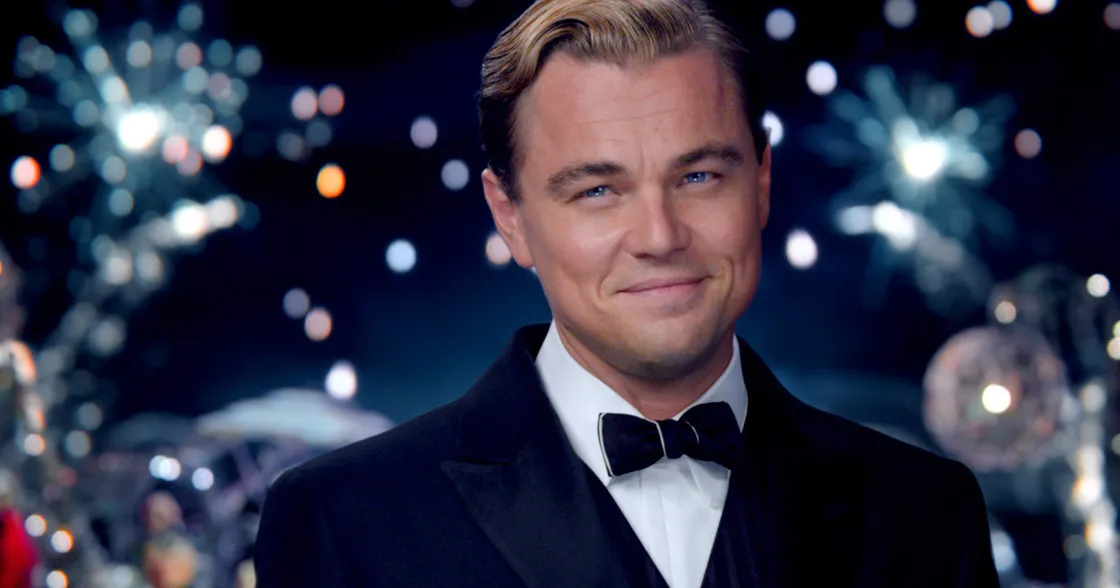Can you describe the main features of this image for me? The image showcases the famous actor dressed impeccably in a classic black tuxedo, which includes a crisp white shirt and a sleek black bowtie. The backdrop is vibrant and lively, featuring an array of sparkling fireworks and party lights that add a festive and celebratory ambiance to the scene. His gaze is directly fixed on the camera, exuding a charismatic and enigmatic charm, complemented by his slight, confident smile. This scene captures a moment filled with elegance, sophistication, and a touch of grandeur, reminiscent of an opulent party setting commonly associated with his character in 'The Great Gatsby'. 